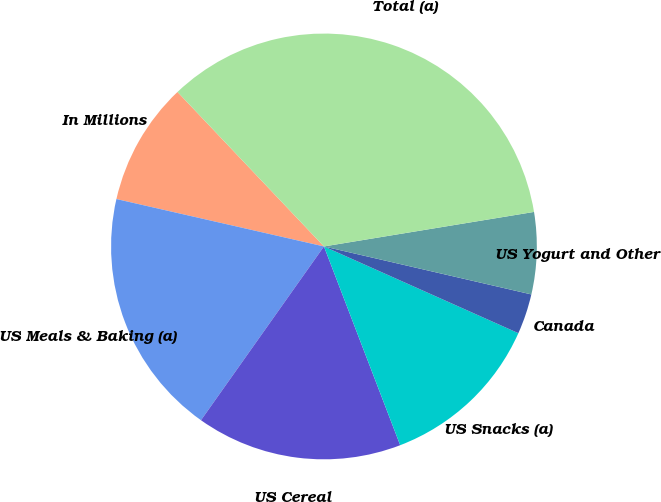Convert chart. <chart><loc_0><loc_0><loc_500><loc_500><pie_chart><fcel>In Millions<fcel>US Meals & Baking (a)<fcel>US Cereal<fcel>US Snacks (a)<fcel>Canada<fcel>US Yogurt and Other<fcel>Total (a)<nl><fcel>9.35%<fcel>18.77%<fcel>15.63%<fcel>12.49%<fcel>3.06%<fcel>6.21%<fcel>34.48%<nl></chart> 